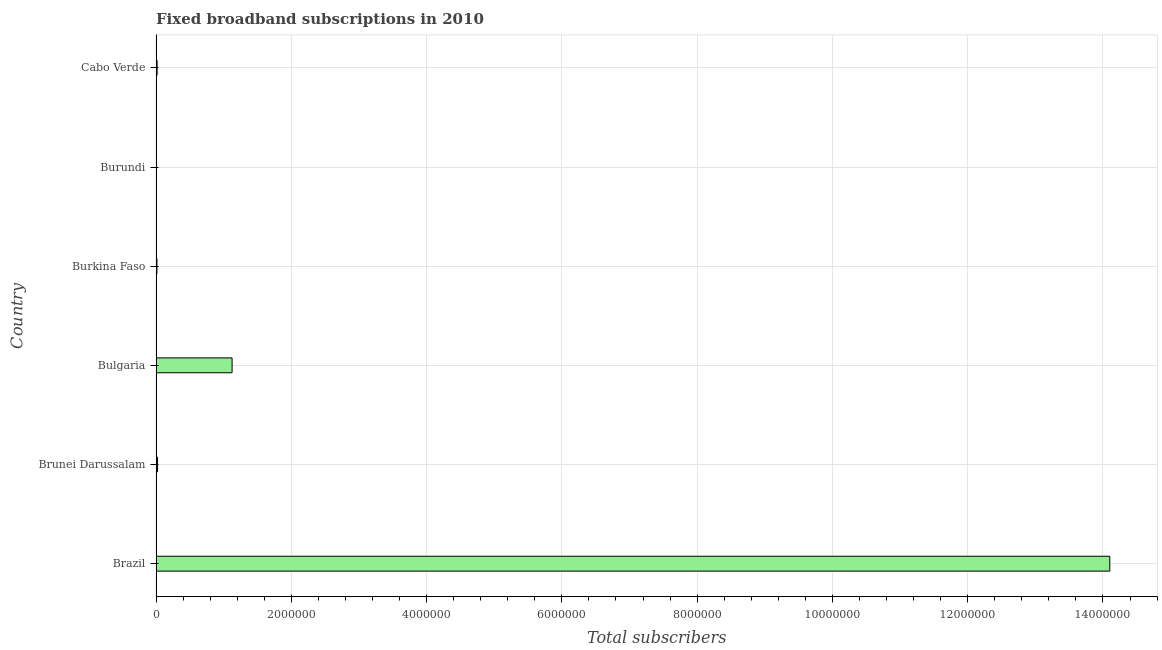What is the title of the graph?
Your answer should be compact. Fixed broadband subscriptions in 2010. What is the label or title of the X-axis?
Your answer should be compact. Total subscribers. What is the label or title of the Y-axis?
Ensure brevity in your answer.  Country. What is the total number of fixed broadband subscriptions in Burkina Faso?
Provide a short and direct response. 1.37e+04. Across all countries, what is the maximum total number of fixed broadband subscriptions?
Offer a terse response. 1.41e+07. Across all countries, what is the minimum total number of fixed broadband subscriptions?
Your response must be concise. 352. In which country was the total number of fixed broadband subscriptions maximum?
Provide a short and direct response. Brazil. In which country was the total number of fixed broadband subscriptions minimum?
Ensure brevity in your answer.  Burundi. What is the sum of the total number of fixed broadband subscriptions?
Keep it short and to the point. 1.53e+07. What is the difference between the total number of fixed broadband subscriptions in Burkina Faso and Cabo Verde?
Provide a short and direct response. -2366. What is the average total number of fixed broadband subscriptions per country?
Offer a very short reply. 2.55e+06. What is the median total number of fixed broadband subscriptions?
Keep it short and to the point. 1.89e+04. What is the ratio of the total number of fixed broadband subscriptions in Bulgaria to that in Burundi?
Your answer should be compact. 3195.24. Is the total number of fixed broadband subscriptions in Bulgaria less than that in Burundi?
Your answer should be very brief. No. Is the difference between the total number of fixed broadband subscriptions in Brazil and Burundi greater than the difference between any two countries?
Offer a terse response. Yes. What is the difference between the highest and the second highest total number of fixed broadband subscriptions?
Offer a terse response. 1.30e+07. Is the sum of the total number of fixed broadband subscriptions in Brunei Darussalam and Burundi greater than the maximum total number of fixed broadband subscriptions across all countries?
Your answer should be very brief. No. What is the difference between the highest and the lowest total number of fixed broadband subscriptions?
Your response must be concise. 1.41e+07. In how many countries, is the total number of fixed broadband subscriptions greater than the average total number of fixed broadband subscriptions taken over all countries?
Your answer should be compact. 1. Are all the bars in the graph horizontal?
Provide a succinct answer. Yes. How many countries are there in the graph?
Make the answer very short. 6. What is the difference between two consecutive major ticks on the X-axis?
Give a very brief answer. 2.00e+06. Are the values on the major ticks of X-axis written in scientific E-notation?
Your response must be concise. No. What is the Total subscribers of Brazil?
Make the answer very short. 1.41e+07. What is the Total subscribers in Brunei Darussalam?
Keep it short and to the point. 2.17e+04. What is the Total subscribers of Bulgaria?
Your response must be concise. 1.12e+06. What is the Total subscribers in Burkina Faso?
Make the answer very short. 1.37e+04. What is the Total subscribers of Burundi?
Provide a short and direct response. 352. What is the Total subscribers of Cabo Verde?
Keep it short and to the point. 1.61e+04. What is the difference between the Total subscribers in Brazil and Brunei Darussalam?
Provide a succinct answer. 1.41e+07. What is the difference between the Total subscribers in Brazil and Bulgaria?
Make the answer very short. 1.30e+07. What is the difference between the Total subscribers in Brazil and Burkina Faso?
Provide a short and direct response. 1.41e+07. What is the difference between the Total subscribers in Brazil and Burundi?
Offer a very short reply. 1.41e+07. What is the difference between the Total subscribers in Brazil and Cabo Verde?
Make the answer very short. 1.41e+07. What is the difference between the Total subscribers in Brunei Darussalam and Bulgaria?
Provide a succinct answer. -1.10e+06. What is the difference between the Total subscribers in Brunei Darussalam and Burkina Faso?
Your answer should be very brief. 7994. What is the difference between the Total subscribers in Brunei Darussalam and Burundi?
Provide a short and direct response. 2.13e+04. What is the difference between the Total subscribers in Brunei Darussalam and Cabo Verde?
Your response must be concise. 5628. What is the difference between the Total subscribers in Bulgaria and Burkina Faso?
Your response must be concise. 1.11e+06. What is the difference between the Total subscribers in Bulgaria and Burundi?
Your answer should be very brief. 1.12e+06. What is the difference between the Total subscribers in Bulgaria and Cabo Verde?
Keep it short and to the point. 1.11e+06. What is the difference between the Total subscribers in Burkina Faso and Burundi?
Your answer should be very brief. 1.34e+04. What is the difference between the Total subscribers in Burkina Faso and Cabo Verde?
Your answer should be very brief. -2366. What is the difference between the Total subscribers in Burundi and Cabo Verde?
Offer a terse response. -1.57e+04. What is the ratio of the Total subscribers in Brazil to that in Brunei Darussalam?
Offer a very short reply. 649.84. What is the ratio of the Total subscribers in Brazil to that in Bulgaria?
Provide a short and direct response. 12.54. What is the ratio of the Total subscribers in Brazil to that in Burkina Faso?
Make the answer very short. 1028.89. What is the ratio of the Total subscribers in Brazil to that in Burundi?
Give a very brief answer. 4.01e+04. What is the ratio of the Total subscribers in Brazil to that in Cabo Verde?
Make the answer very short. 877.41. What is the ratio of the Total subscribers in Brunei Darussalam to that in Bulgaria?
Your response must be concise. 0.02. What is the ratio of the Total subscribers in Brunei Darussalam to that in Burkina Faso?
Offer a terse response. 1.58. What is the ratio of the Total subscribers in Brunei Darussalam to that in Burundi?
Provide a short and direct response. 61.65. What is the ratio of the Total subscribers in Brunei Darussalam to that in Cabo Verde?
Offer a terse response. 1.35. What is the ratio of the Total subscribers in Bulgaria to that in Burkina Faso?
Provide a short and direct response. 82.07. What is the ratio of the Total subscribers in Bulgaria to that in Burundi?
Provide a succinct answer. 3195.24. What is the ratio of the Total subscribers in Bulgaria to that in Cabo Verde?
Your answer should be very brief. 69.98. What is the ratio of the Total subscribers in Burkina Faso to that in Burundi?
Offer a terse response. 38.94. What is the ratio of the Total subscribers in Burkina Faso to that in Cabo Verde?
Your answer should be compact. 0.85. What is the ratio of the Total subscribers in Burundi to that in Cabo Verde?
Your answer should be compact. 0.02. 